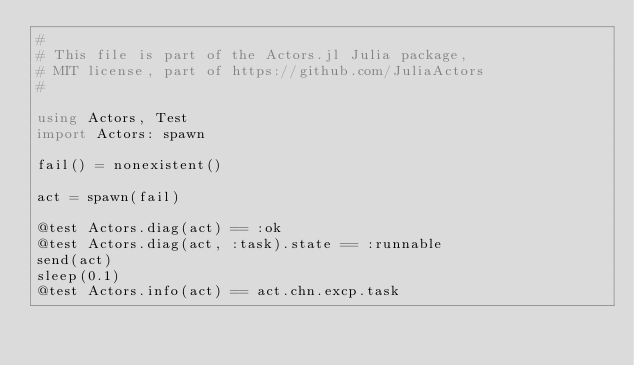Convert code to text. <code><loc_0><loc_0><loc_500><loc_500><_Julia_>#
# This file is part of the Actors.jl Julia package, 
# MIT license, part of https://github.com/JuliaActors
#

using Actors, Test
import Actors: spawn

fail() = nonexistent()

act = spawn(fail)

@test Actors.diag(act) == :ok
@test Actors.diag(act, :task).state == :runnable
send(act)
sleep(0.1)
@test Actors.info(act) == act.chn.excp.task
</code> 